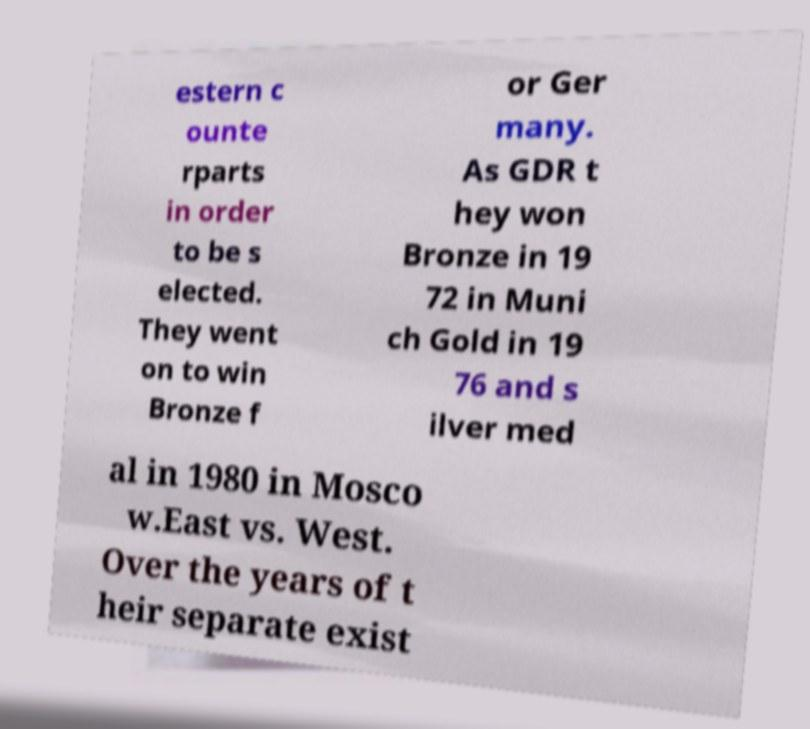There's text embedded in this image that I need extracted. Can you transcribe it verbatim? estern c ounte rparts in order to be s elected. They went on to win Bronze f or Ger many. As GDR t hey won Bronze in 19 72 in Muni ch Gold in 19 76 and s ilver med al in 1980 in Mosco w.East vs. West. Over the years of t heir separate exist 